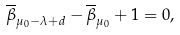Convert formula to latex. <formula><loc_0><loc_0><loc_500><loc_500>\overline { \beta } _ { \mu _ { 0 } - \lambda + d } - \overline { \beta } _ { \mu _ { 0 } } + 1 = 0 ,</formula> 